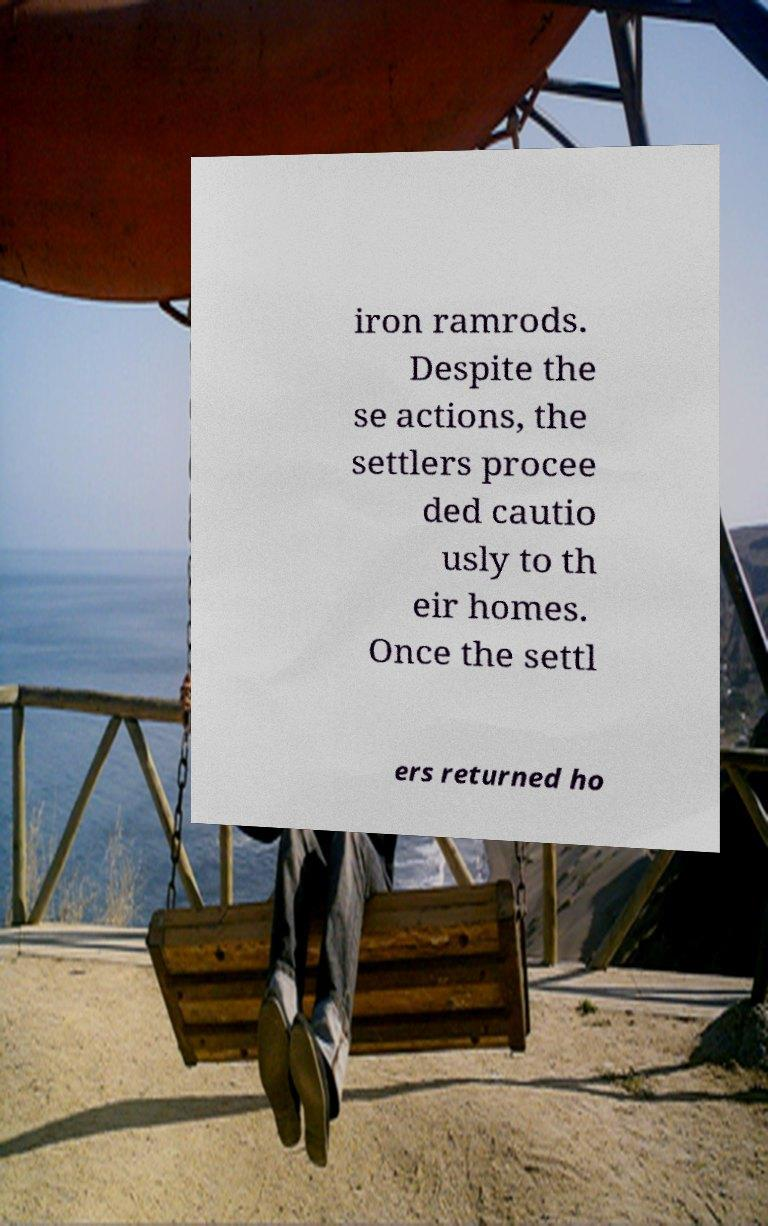Please read and relay the text visible in this image. What does it say? iron ramrods. Despite the se actions, the settlers procee ded cautio usly to th eir homes. Once the settl ers returned ho 